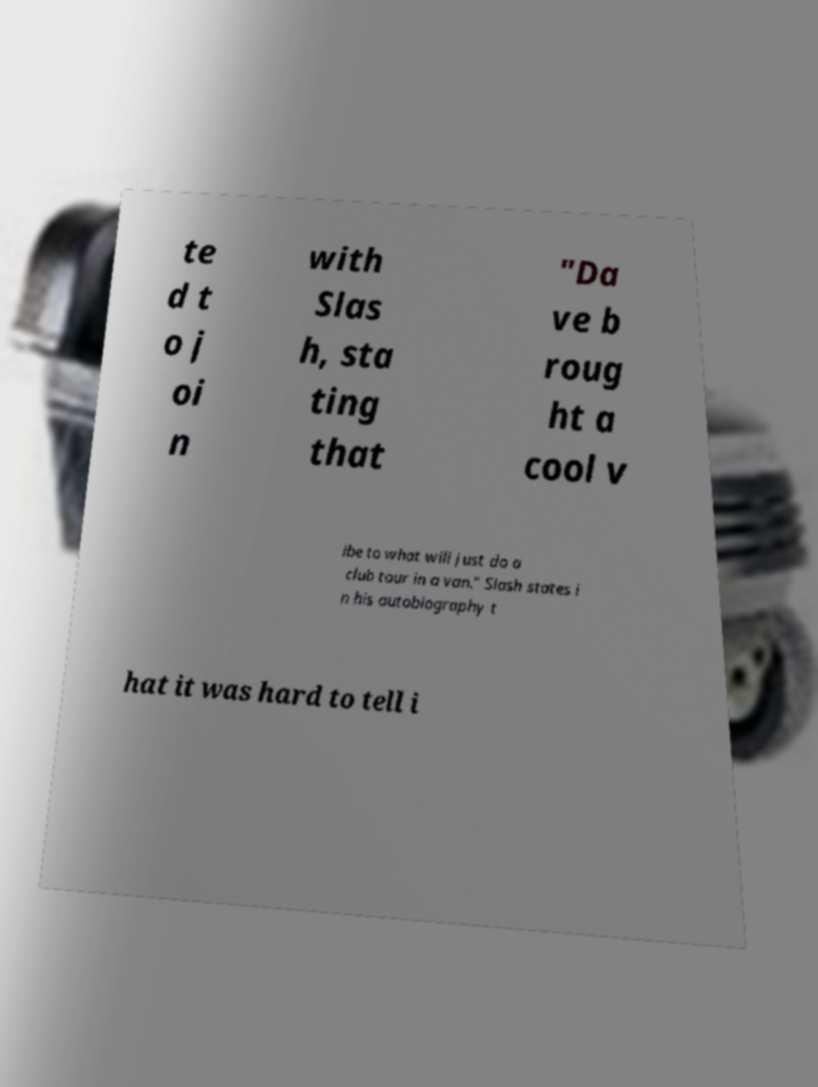There's text embedded in this image that I need extracted. Can you transcribe it verbatim? te d t o j oi n with Slas h, sta ting that "Da ve b roug ht a cool v ibe to what will just do a club tour in a van." Slash states i n his autobiography t hat it was hard to tell i 